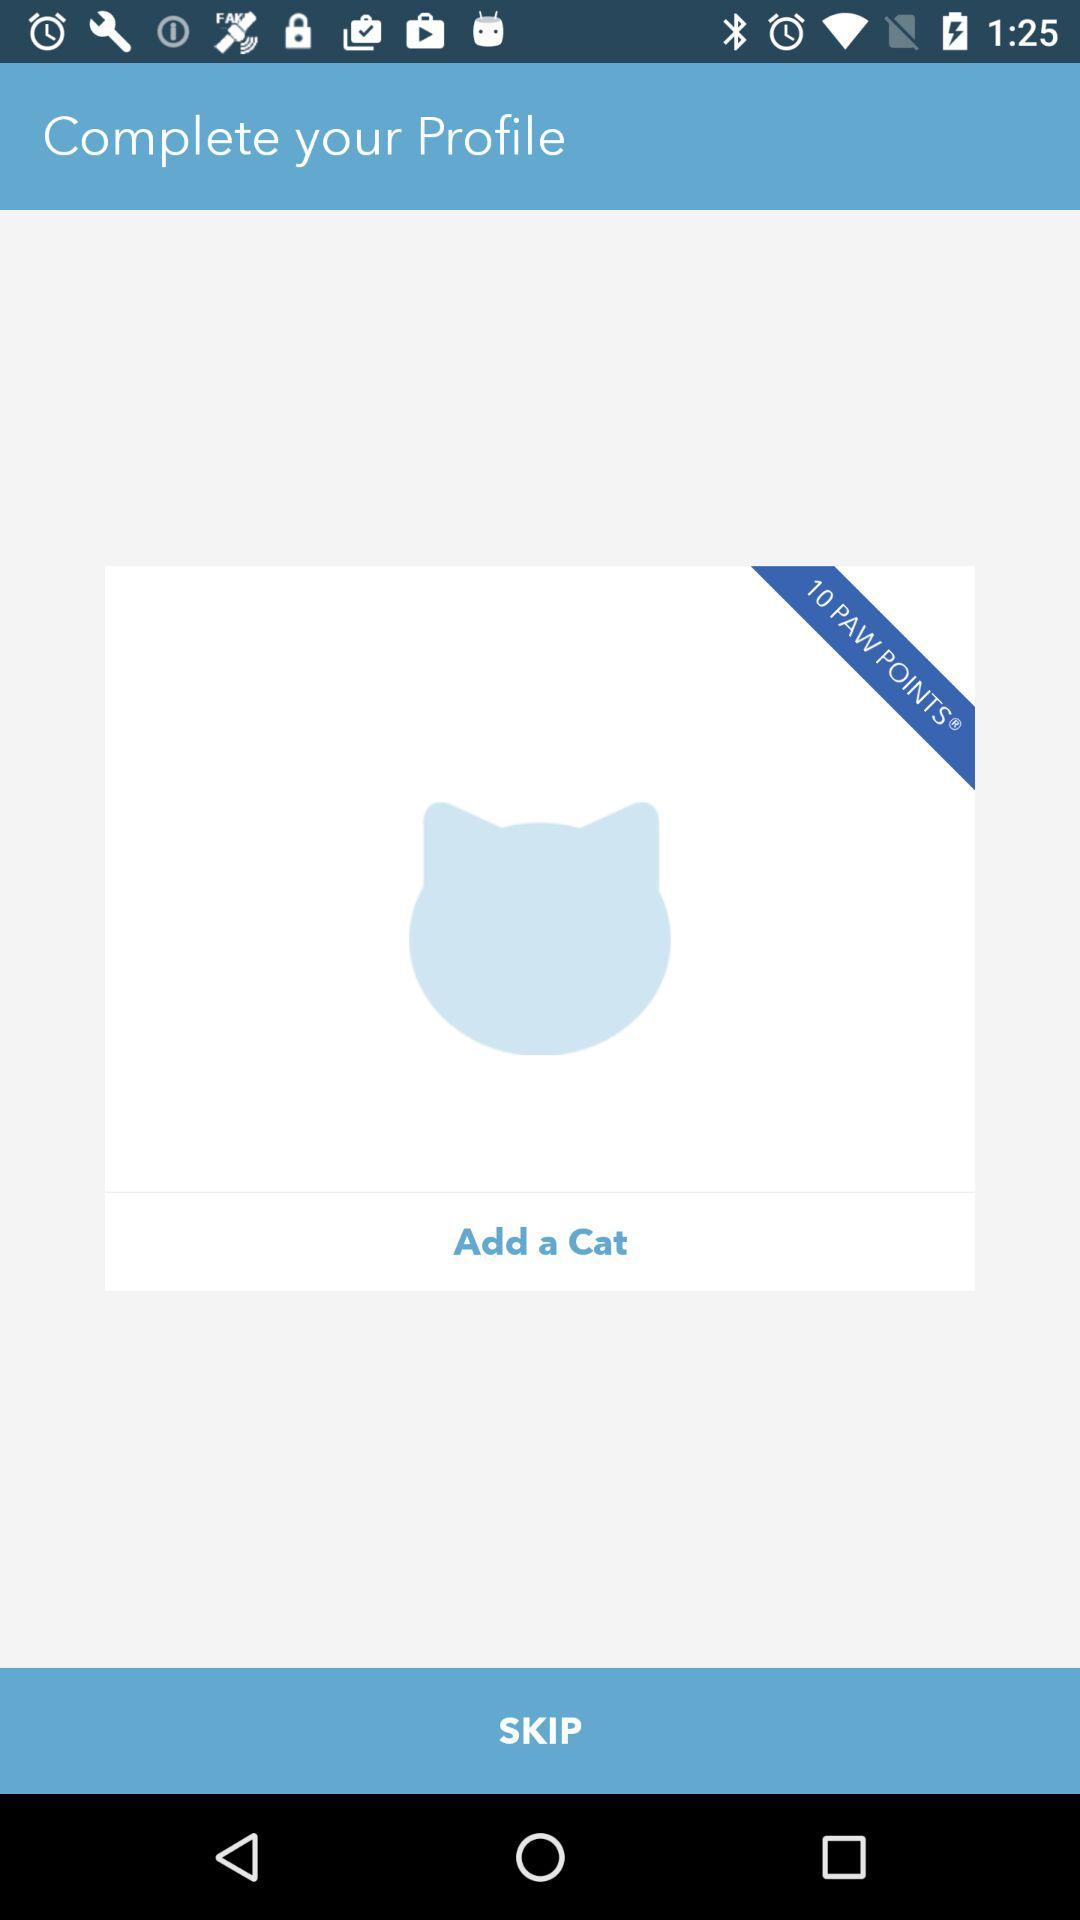How many more paw points do I need to unlock the next cat?
Answer the question using a single word or phrase. 10 